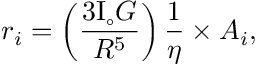Convert formula to latex. <formula><loc_0><loc_0><loc_500><loc_500>r _ { i } = \left ( \frac { 3 I _ { \circ } G } { R ^ { 5 } } \right ) \frac { 1 } { \eta } \times A _ { i } ,</formula> 